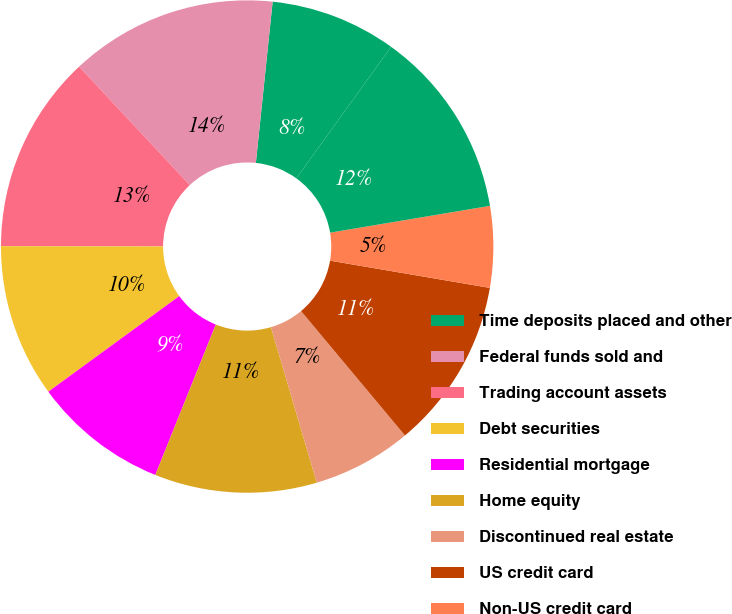<chart> <loc_0><loc_0><loc_500><loc_500><pie_chart><fcel>Time deposits placed and other<fcel>Federal funds sold and<fcel>Trading account assets<fcel>Debt securities<fcel>Residential mortgage<fcel>Home equity<fcel>Discontinued real estate<fcel>US credit card<fcel>Non-US credit card<fcel>Direct/Indirect consumer<nl><fcel>8.29%<fcel>13.61%<fcel>13.02%<fcel>10.06%<fcel>8.88%<fcel>10.65%<fcel>6.51%<fcel>11.24%<fcel>5.33%<fcel>12.42%<nl></chart> 